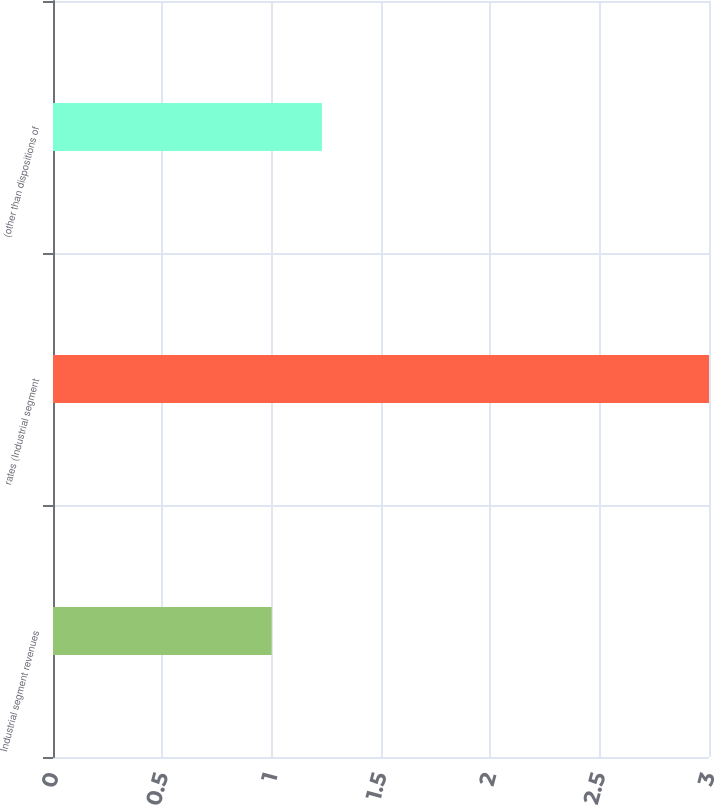Convert chart to OTSL. <chart><loc_0><loc_0><loc_500><loc_500><bar_chart><fcel>Industrial segment revenues<fcel>rates (Industrial segment<fcel>(other than dispositions of<nl><fcel>1<fcel>3<fcel>1.23<nl></chart> 